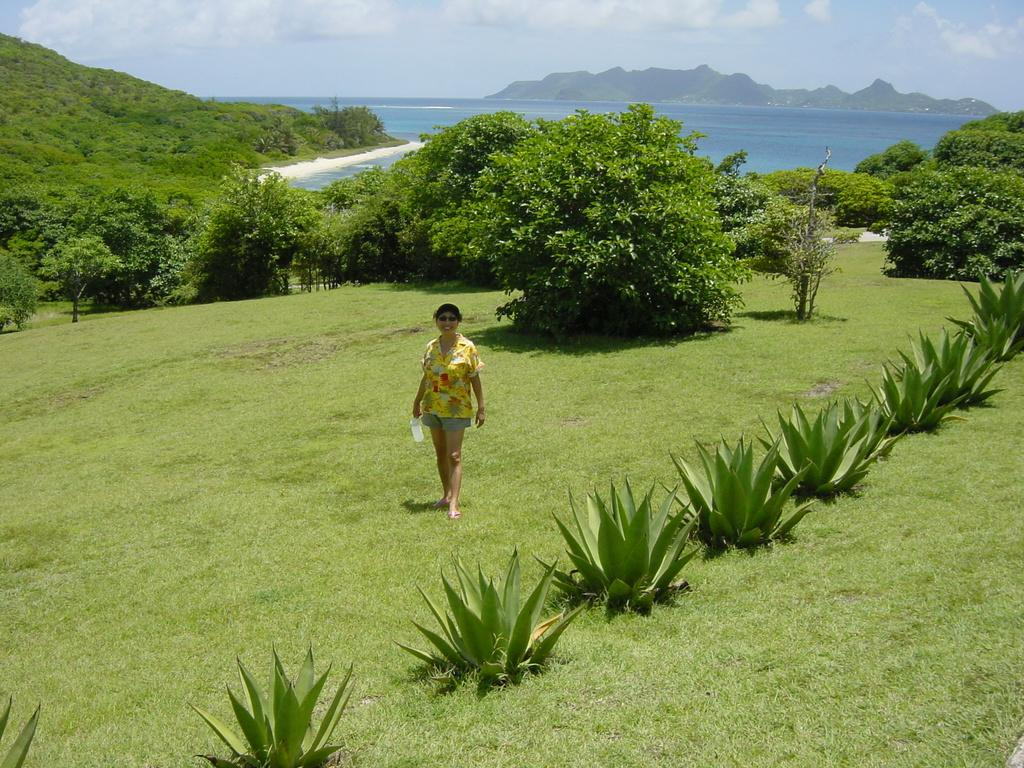What is the person in the image doing? The person is standing on the ground in the image. What type of vegetation can be seen in the image? There are plants, grass, and trees visible in the image. What natural feature can be seen in the background of the image? There is a mountain in the background of the image. What is visible in the sky in the image? The sky is visible in the background of the image, and clouds are present. What type of leather hat is the dad wearing in the image? There is no dad or hat present in the image; it only features a person standing on the ground. 